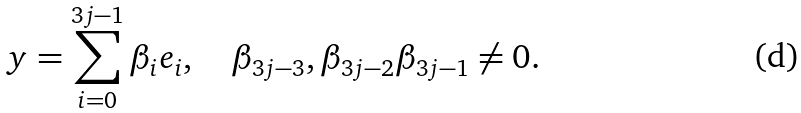Convert formula to latex. <formula><loc_0><loc_0><loc_500><loc_500>y = \sum _ { i = 0 } ^ { 3 j - 1 } \beta _ { i } e _ { i } , \quad \beta _ { 3 j - 3 } , \beta _ { 3 j - 2 } \beta _ { 3 j - 1 } \neq 0 .</formula> 